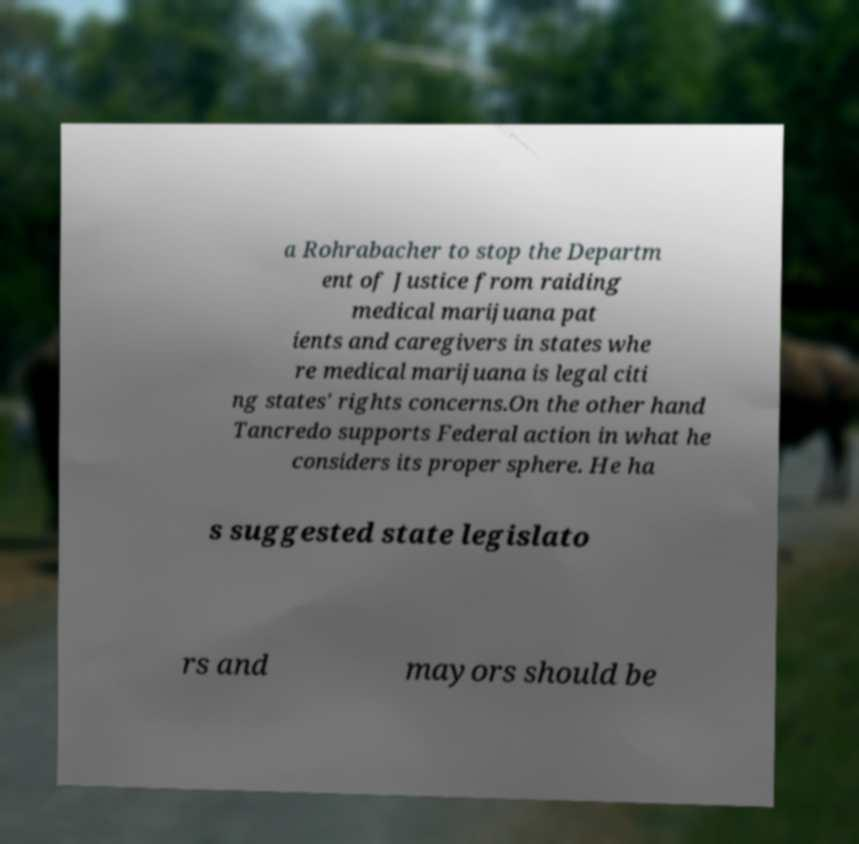Could you extract and type out the text from this image? a Rohrabacher to stop the Departm ent of Justice from raiding medical marijuana pat ients and caregivers in states whe re medical marijuana is legal citi ng states' rights concerns.On the other hand Tancredo supports Federal action in what he considers its proper sphere. He ha s suggested state legislato rs and mayors should be 